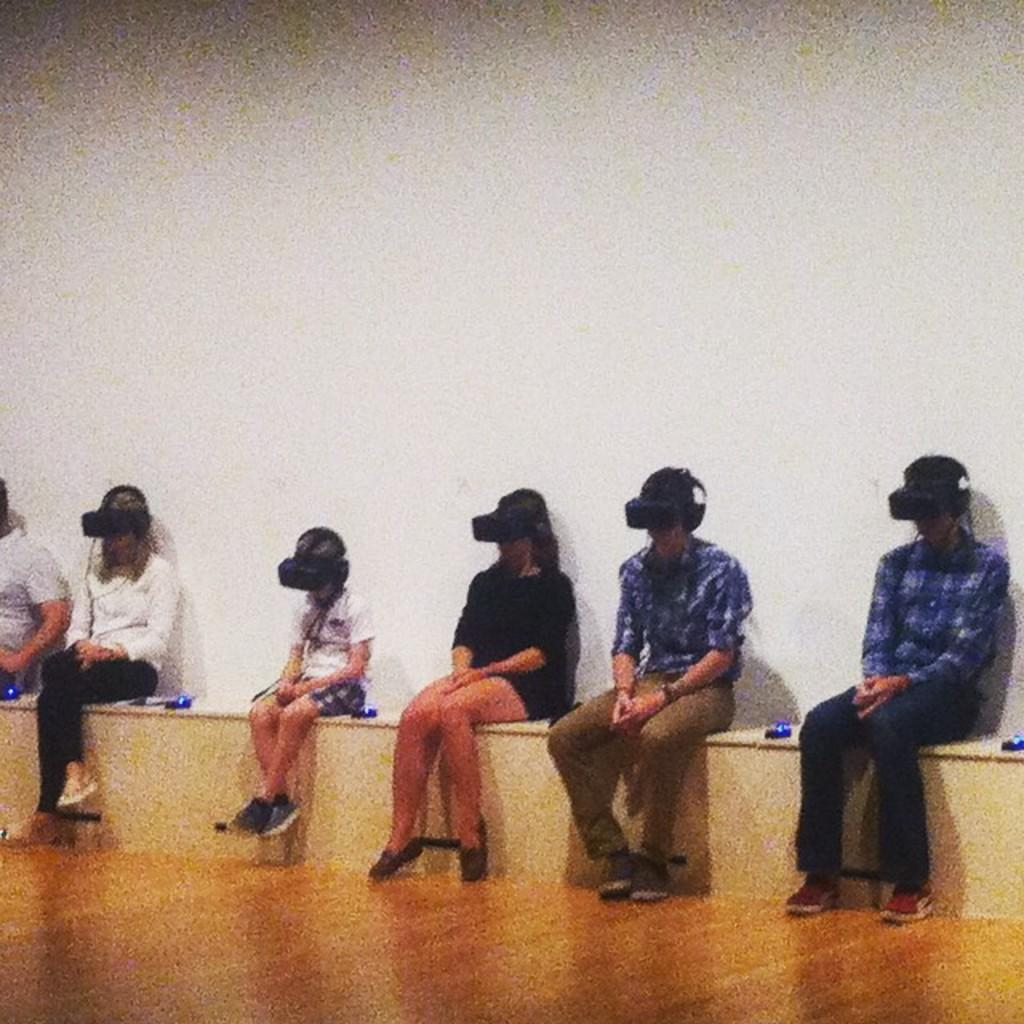Who or what is present in the image? There are people in the image. What are the people wearing? The people are wearing VR boxes. What can be seen in the background of the image? There is a wall in the background of the image. What type of flooring is visible at the bottom of the image? There is wooden flooring at the bottom of the image. What type of tramp can be seen in the image? There is no tramp present in the image. Can you describe the fangs of the creature in the image? There is no creature with fangs present in the image. 